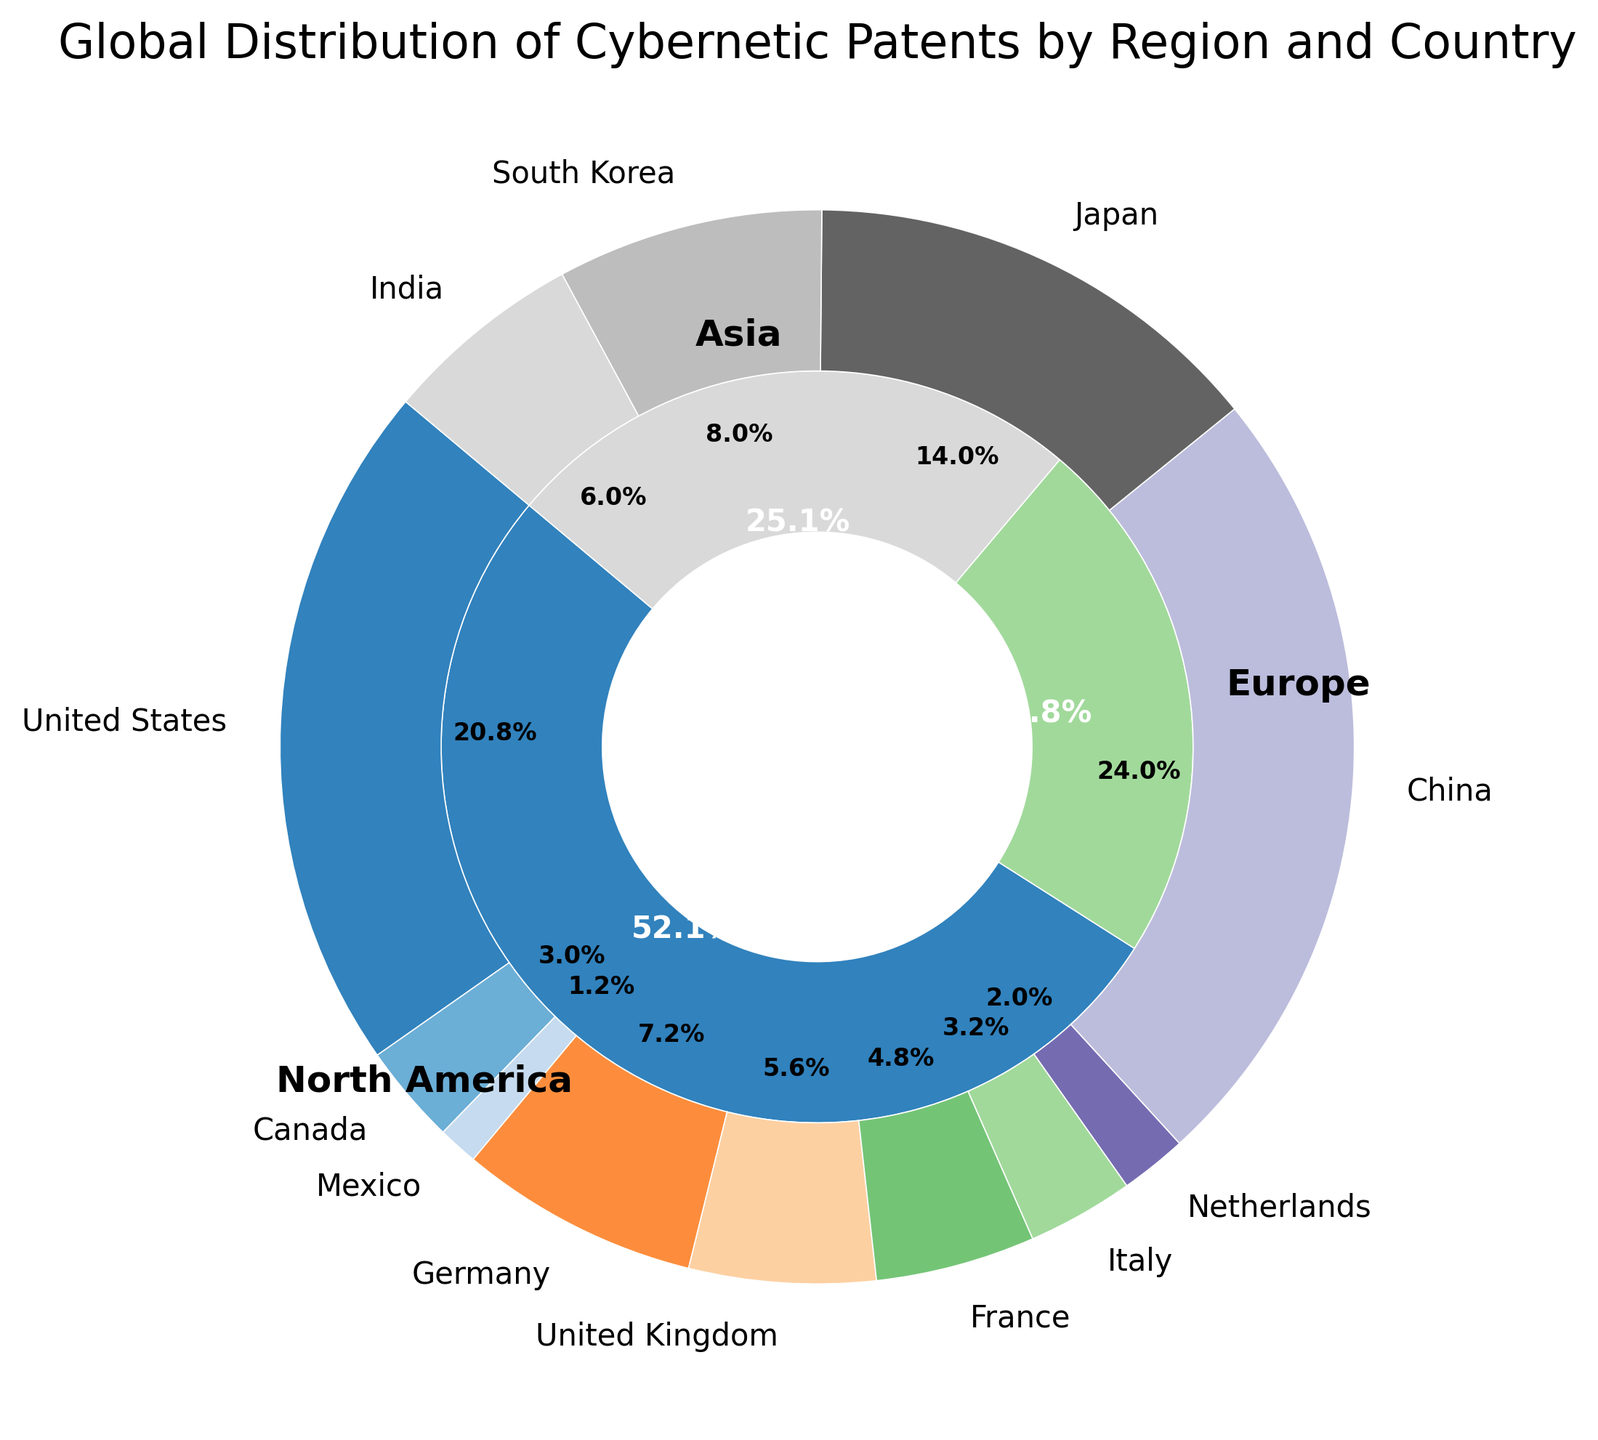Which region has the highest proportion of cybernetic patents? The larger segment by region at the inner level shows the proportion. Asia has the largest segment.
Answer: Asia What percentage of the total cybernetic patents are from Europe? Observe the inner pie segments for Europe. According to the labels, Europe has 22.7% of the total.
Answer: 22.7% Which country contributes the most patents in Asia? Look at the outer segments within the Asia region part of the inner pie. According to the labels, China has the largest segment.
Answer: China What is the sum of patents from Germany and the United Kingdom? From the outer segments, Germany has 180 patents and the United Kingdom has 140 patents. Adding them, 180 + 140 = 320.
Answer: 320 Does North America have more cybernetic patents than Europe? The inner pie shows that North America has a larger segment compared to Europe. North America has 32.8% and Europe has 22.7%.
Answer: Yes, North America has more Which country contributes the least patents within Europe? Look at the labels of the outer segments in the Europe section. The Netherlands has the smallest percentage within Europe.
Answer: Netherlands How do China's cybernetic patents compare to the total patents from North America? China has 600 patents, which you find in the outer segments. North America has a total of 625 (520 from the United States, 75 from Canada, and 30 from Mexico). Comparing them, 600 is slightly less than 625.
Answer: Just slightly less What is the total percentage of patents from China and Japan? Find the individual percentages for China (600 patents) and Japan (350 patents). Together, they sum up to 950 patents. Calculate (600+350) / TotalPatents.
Answer: 43.7% Which country within North America has the highest number of patents? Review the percentages in the outer segments within the North America part of the pie. The United States has the largest segment.
Answer: United States What is the average number of patents for the countries in Europe? Sum the patents from Germany, United Kingdom, France, Italy, and Netherlands: 180 + 140 + 120 + 80 + 50 = 570. There are 5 countries, so the average is 570/5 = 114.
Answer: 114 